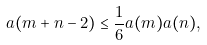<formula> <loc_0><loc_0><loc_500><loc_500>a ( m + n - 2 ) \leq \frac { 1 } { 6 } a ( m ) a ( n ) ,</formula> 